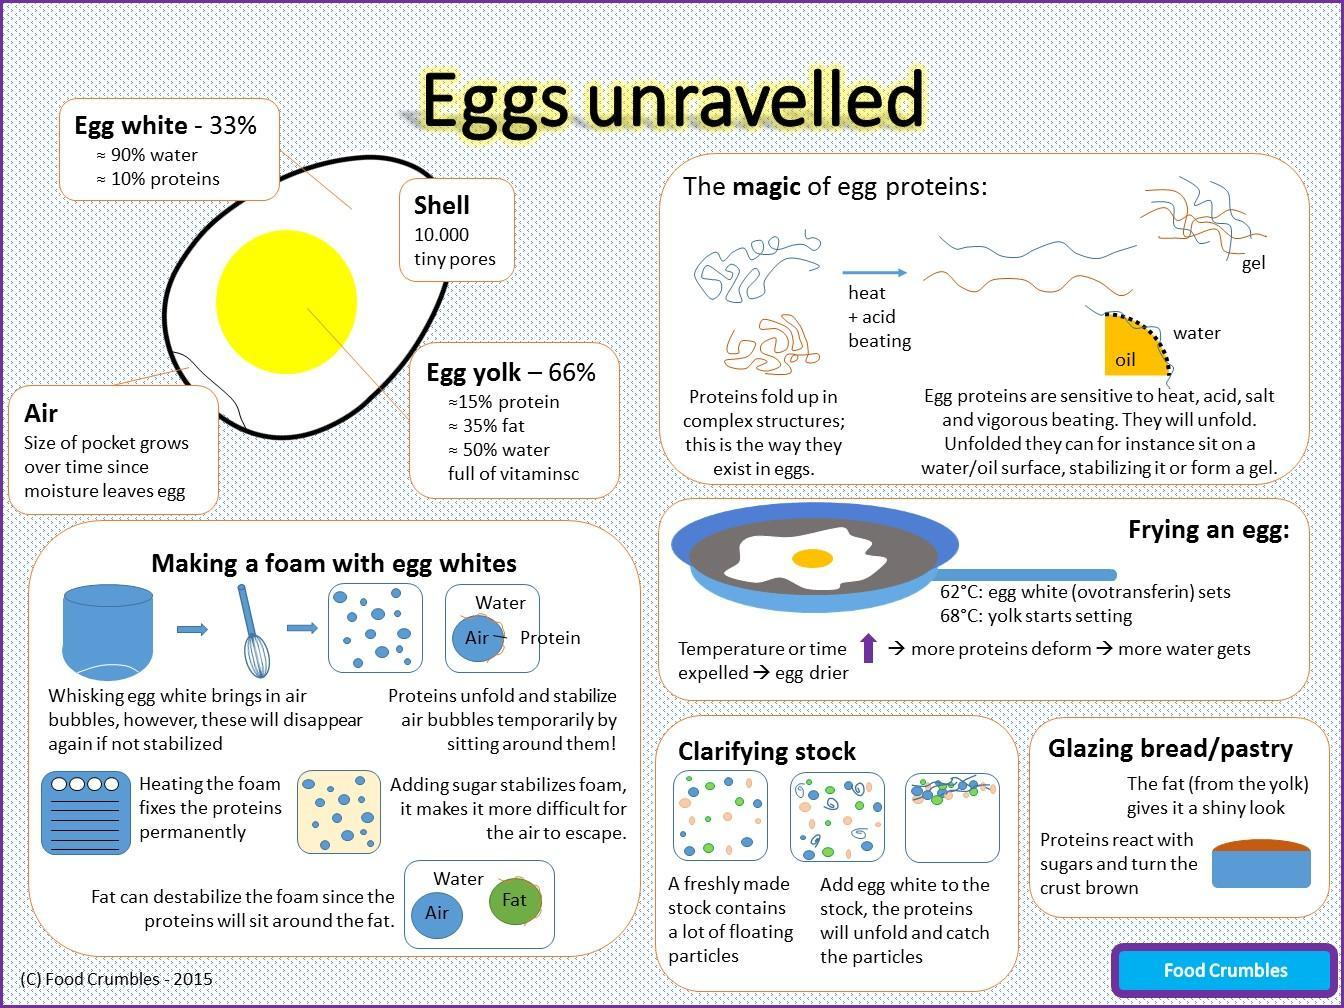What does adding sugar do to the foam - destabilise it, stabilize it or no change at all?
Answer the question with a short phrase. Stabilize it Which contains more water ; egg white or egg yolk? Egg white What are the three main 'visible' parts of an egg? Egg shell, egg white, egg yolk What percent of the egg white comprises of water? 90% Which contains more protein; egg white or egg yolk? Egg yolk Which 'parts' of the egg are rich in proteins? Egg white, egg yolk What can fix the proteins permanently, while making foam? Heating the foam What happens to the size of the air pocket within the egg - decreases, increases or remains the same? Increases While frying an egg, which part is slower to set? Egg yolks How many pores does the egg shell have? 10,000 Which part of the egg, is rich in fats and vitamins? Egg yolk What does fat do to the foam - stabilize it, destabilize it or no change at all? Destabilise it What percent of the egg yolk comprises of water? 50% Which part of egg is used to make foam? Egg white While frying an egg, which part sets faster? Egg white What percent of egg yolk comprises of fat? 35% 